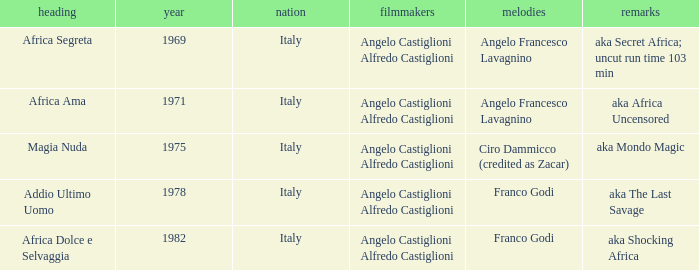What is the country that has a music writer of Angelo Francesco Lavagnino, written in 1969? Italy. 